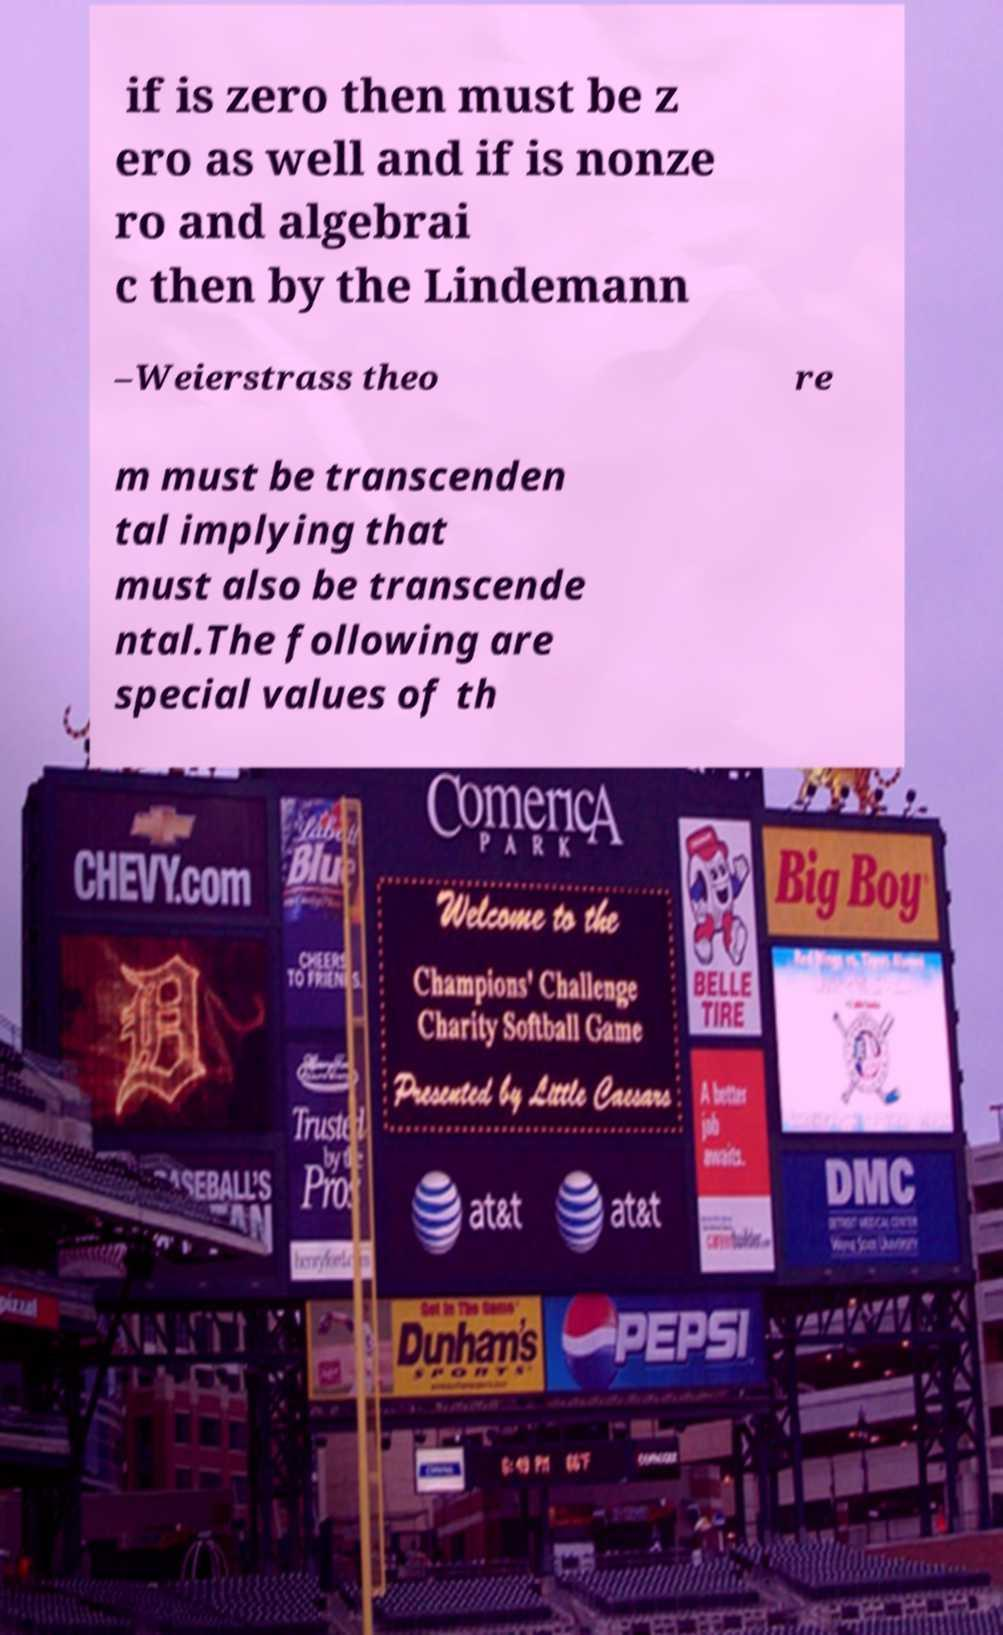Please read and relay the text visible in this image. What does it say? if is zero then must be z ero as well and if is nonze ro and algebrai c then by the Lindemann –Weierstrass theo re m must be transcenden tal implying that must also be transcende ntal.The following are special values of th 